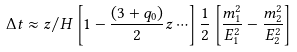Convert formula to latex. <formula><loc_0><loc_0><loc_500><loc_500>\Delta t \approx z / H \left [ 1 - \frac { ( 3 + q _ { 0 } ) } { 2 } z \cdots \right ] \frac { 1 } { 2 } \left [ \frac { m _ { 1 } ^ { 2 } } { E _ { 1 } ^ { 2 } } - \frac { m _ { 2 } ^ { 2 } } { E _ { 2 } ^ { 2 } } \right ]</formula> 